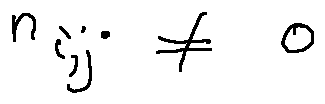<formula> <loc_0><loc_0><loc_500><loc_500>n _ { i , j } \neq 0</formula> 